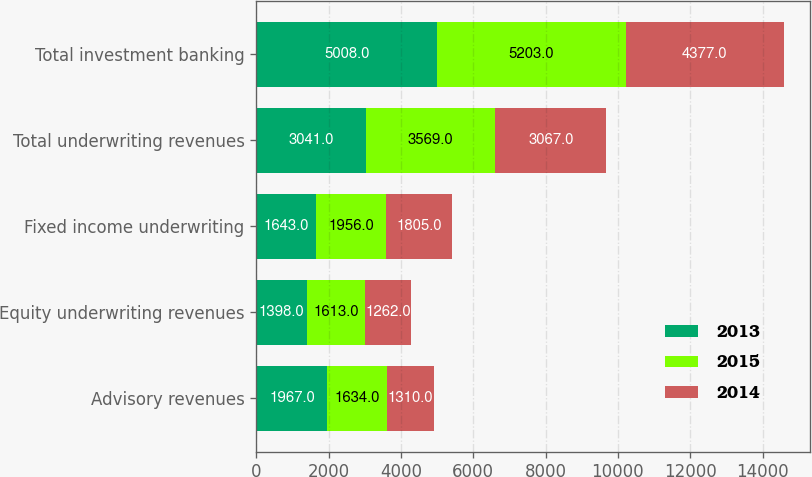<chart> <loc_0><loc_0><loc_500><loc_500><stacked_bar_chart><ecel><fcel>Advisory revenues<fcel>Equity underwriting revenues<fcel>Fixed income underwriting<fcel>Total underwriting revenues<fcel>Total investment banking<nl><fcel>2013<fcel>1967<fcel>1398<fcel>1643<fcel>3041<fcel>5008<nl><fcel>2015<fcel>1634<fcel>1613<fcel>1956<fcel>3569<fcel>5203<nl><fcel>2014<fcel>1310<fcel>1262<fcel>1805<fcel>3067<fcel>4377<nl></chart> 